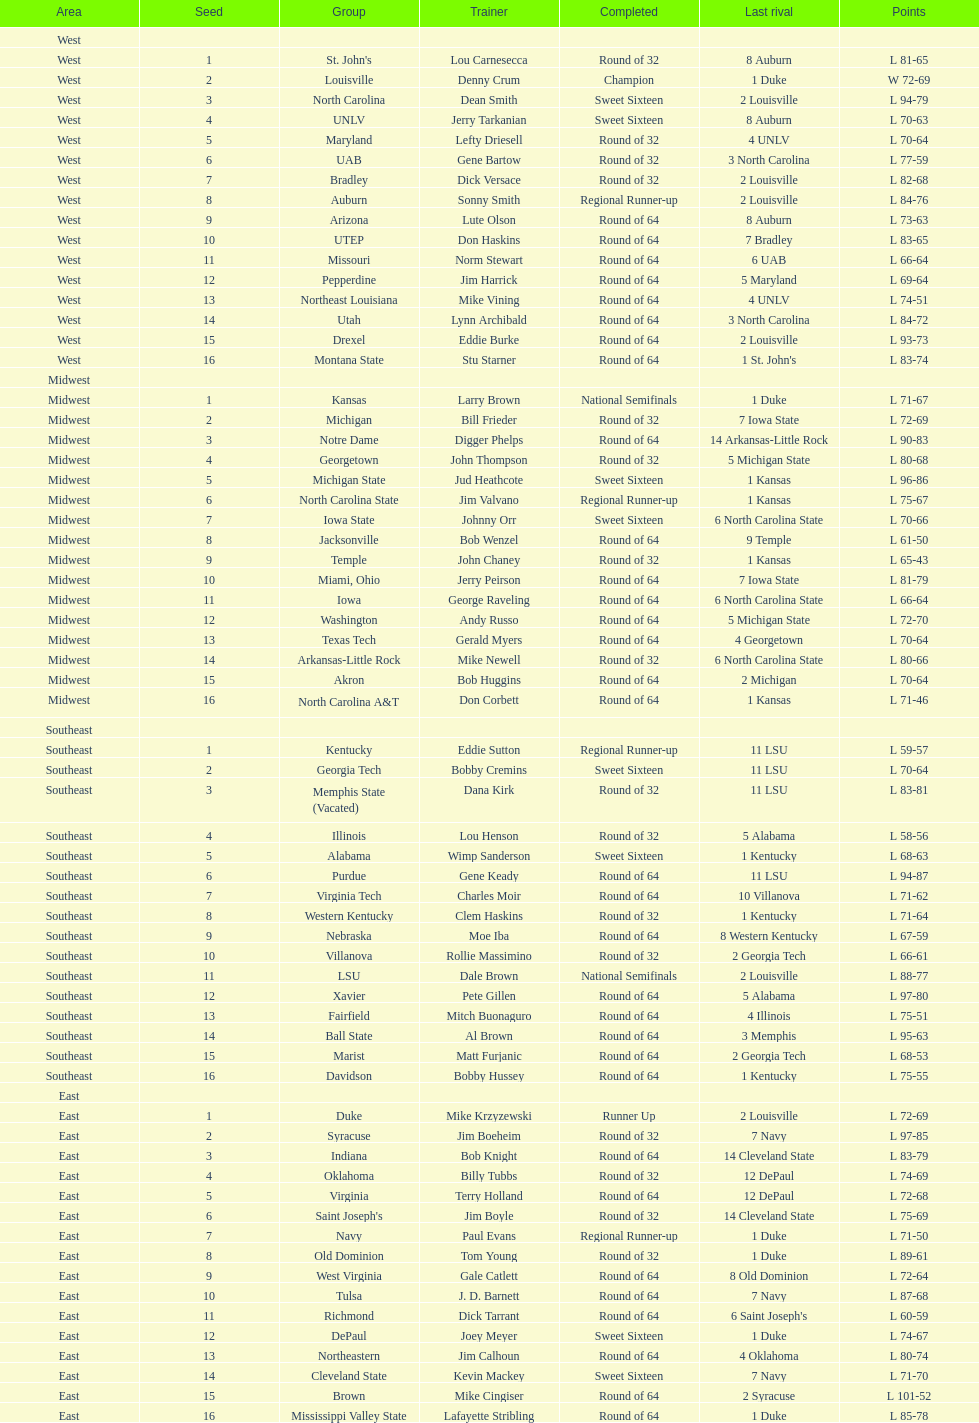How many teams are in the east region. 16. 